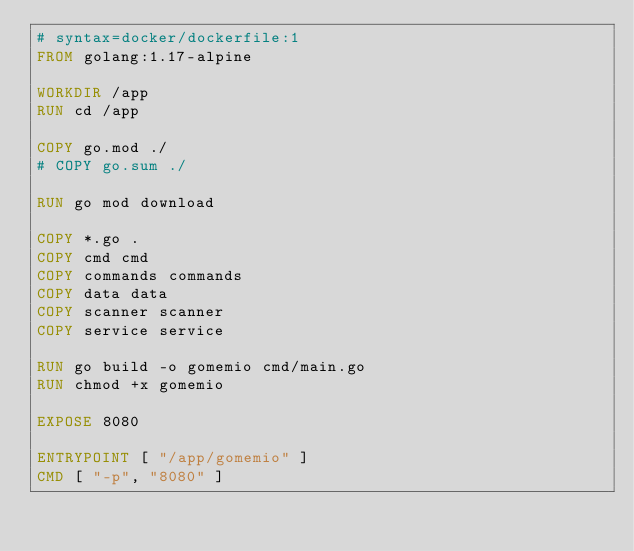Convert code to text. <code><loc_0><loc_0><loc_500><loc_500><_Dockerfile_># syntax=docker/dockerfile:1
FROM golang:1.17-alpine

WORKDIR /app
RUN cd /app

COPY go.mod ./
# COPY go.sum ./

RUN go mod download

COPY *.go .
COPY cmd cmd
COPY commands commands
COPY data data
COPY scanner scanner
COPY service service

RUN go build -o gomemio cmd/main.go
RUN chmod +x gomemio

EXPOSE 8080

ENTRYPOINT [ "/app/gomemio" ]
CMD [ "-p", "8080" ]
</code> 